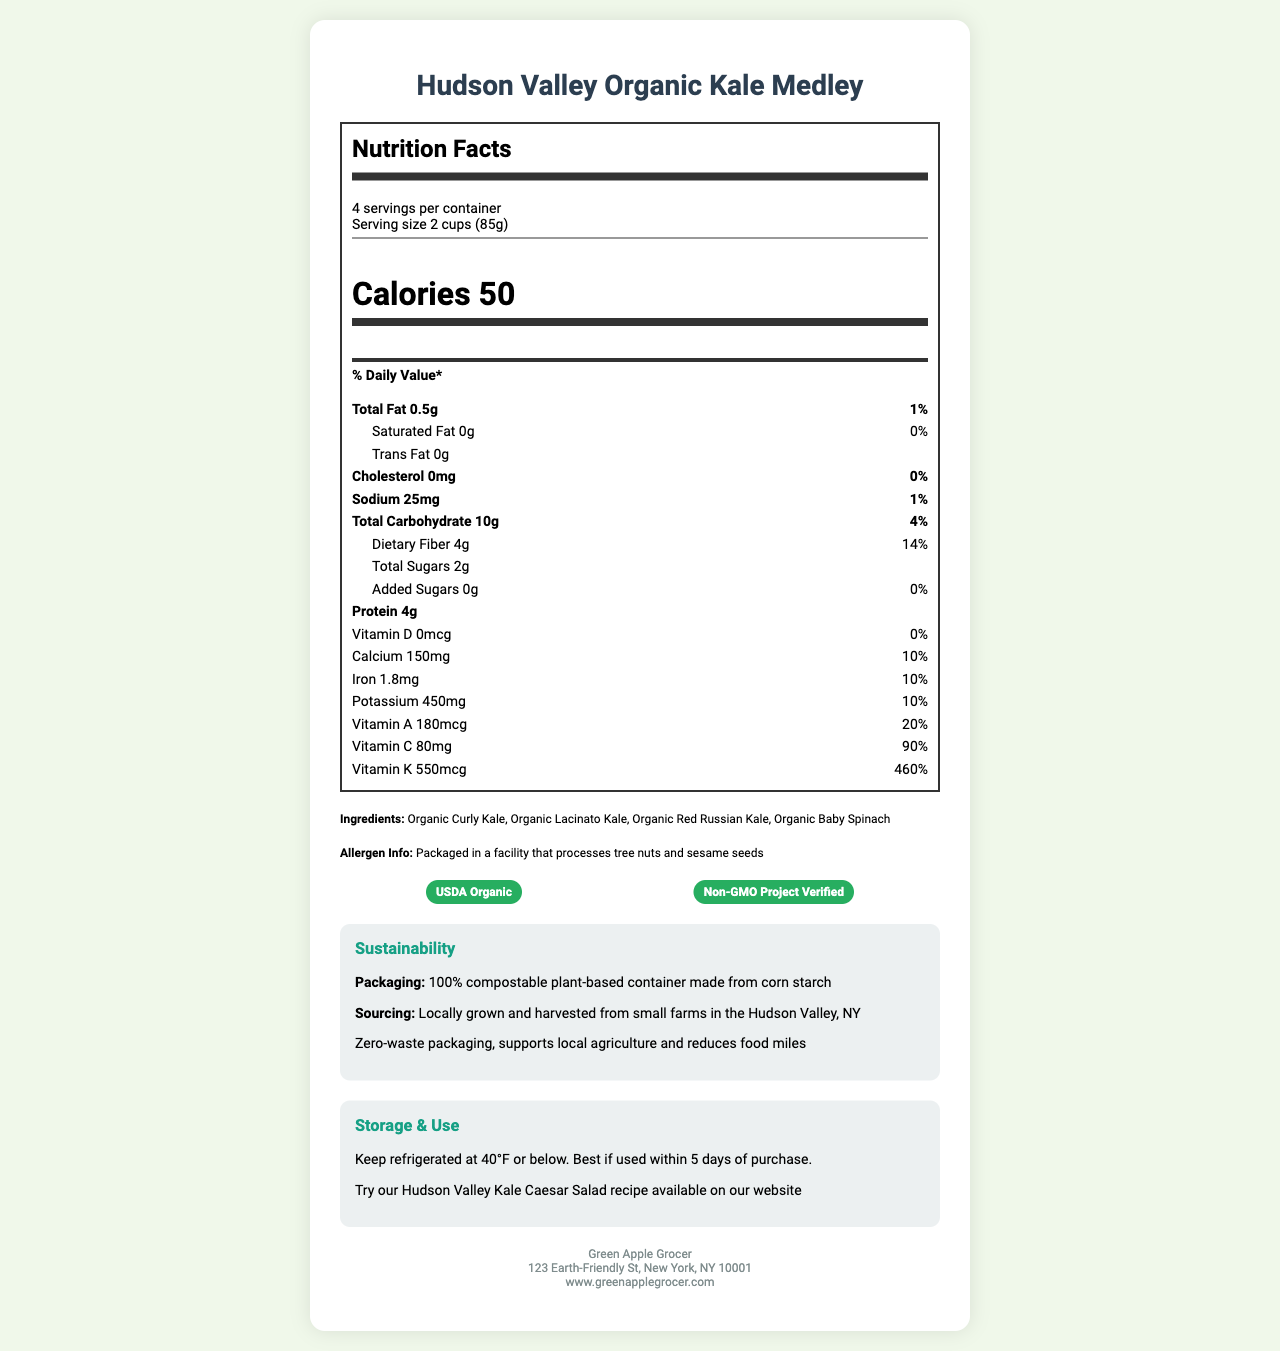what is the serving size? The serving size is stated at the beginning of the Nutrition Facts label as "2 cups (85g)".
Answer: 2 cups (85g) how many servings per container? It is mentioned right beside the serving size as "4 servings per container".
Answer: 4 what is the amount of total fat in one serving? The total fat per serving is listed under the "Total Fat" section as "0.5g".
Answer: 0.5g what is the percentage of the daily value for dietary fiber? The daily value percentage for dietary fiber is indicated as "14%" under the "Dietary Fiber" section.
Answer: 14% how much added sugars are in one serving? The amount of added sugars is stated as "0g" in the sub-section of "Total Sugars".
Answer: 0g what are the main ingredients of this product? The ingredients are mentioned towards the end of the document as "Organic Curly Kale, Organic Lacinato Kale, Organic Red Russian Kale, Organic Baby Spinach".
Answer: Organic Curly Kale, Organic Lacinato Kale, Organic Red Russian Kale, Organic Baby Spinach where is the source of the kale medley? A. California B. Florida C. Hudson Valley, NY D. Midwest The sourcing information reveals that it is grown and harvested from small farms in the Hudson Valley, NY.
Answer: C which vitamin has the highest daily value percentage in one serving? 1. Vitamin A 2. Vitamin C 3. Vitamin D 4. Vitamin K Vitamin K has the highest daily value percentage listed as "460%" compared to the others.
Answer: 4 is this product certified as organic? The certification section includes "USDA Organic".
Answer: Yes is there cholesterol in one serving of this product? The cholesterol amount is listed as "0mg" with a 0% daily value, indicating no cholesterol.
Answer: No summarize the main nutritional and sustainability aspects of the product. The document highlights the nutritional benefits of the kale medley, including high dietary fiber and vitamin content while emphasizing its eco-friendly, locally-sourced, and compostable packaging.
Answer: The Hudson Valley Organic Kale Medley is a low-calorie, nutrient-rich product with a high percentage of daily values for dietary fiber, vitamins A, C, and K. It is locally sourced from small farms in Hudson Valley, NY, and packaged in 100% compostable plant-based material, making it a sustainable and eco-friendly choice. what is the cost of one container of this product? The document does not provide any information about the price of the product.
Answer: Cannot be determined 